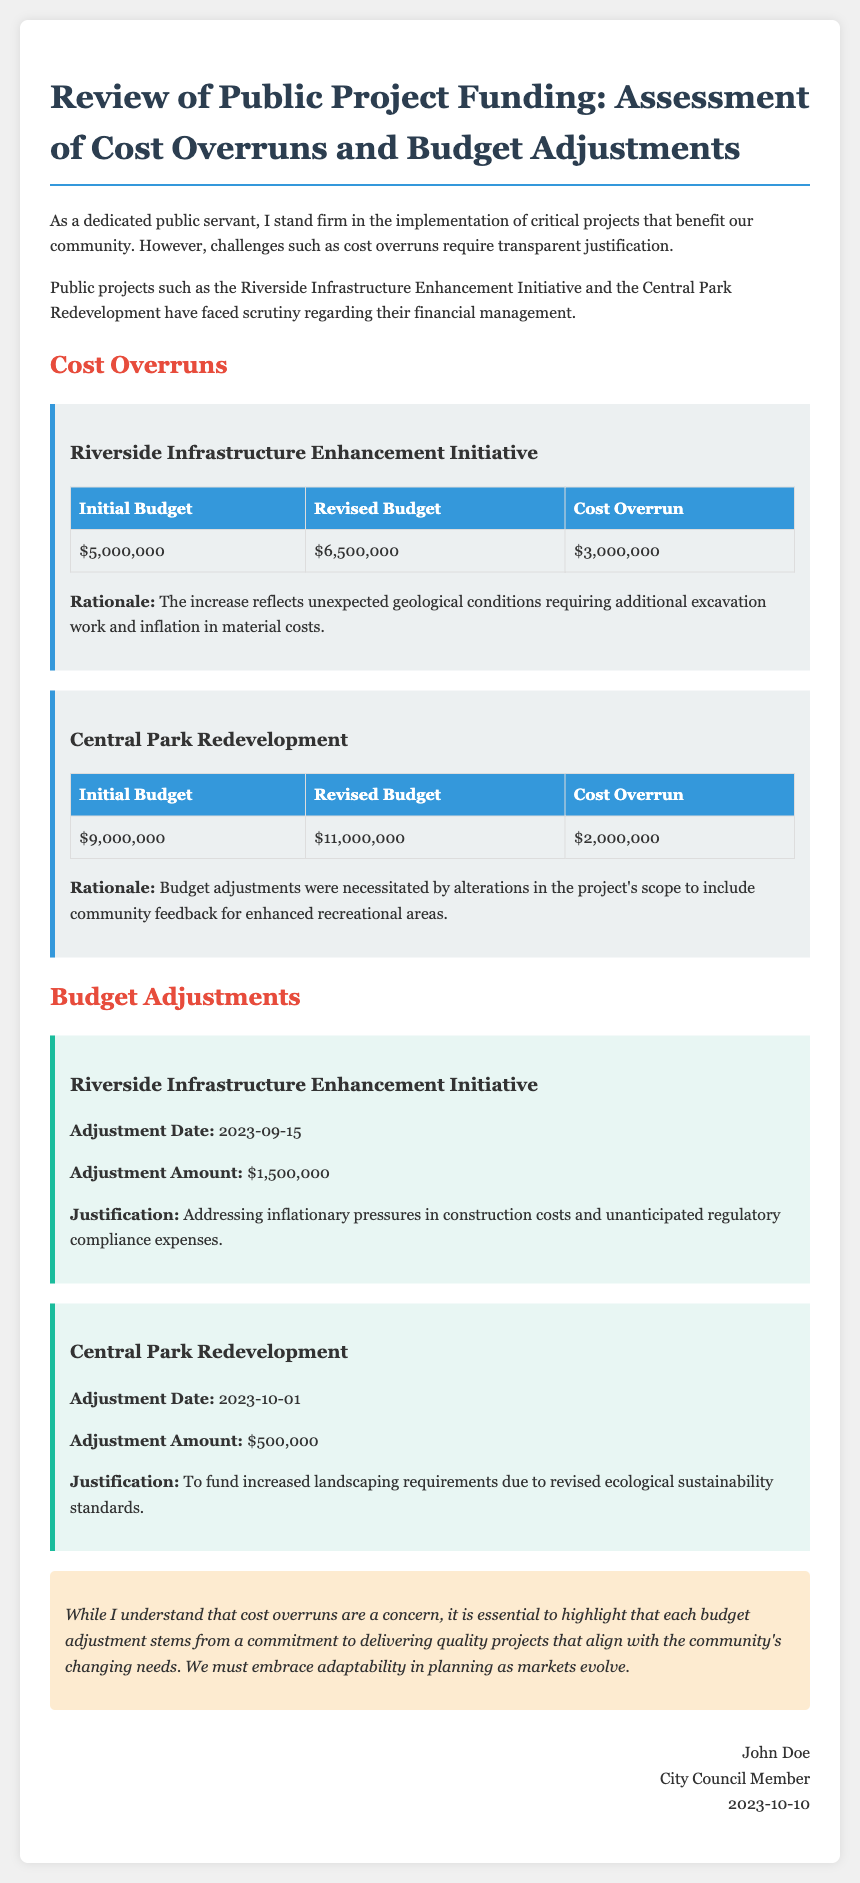What is the initial budget for the Riverside Infrastructure Enhancement Initiative? The initial budget is stated in the project funding table for the Riverside Infrastructure Enhancement Initiative, which is $5,000,000.
Answer: $5,000,000 What is the revised budget for the Central Park Redevelopment? The revised budget is provided in the project funding table for the Central Park Redevelopment, which is $11,000,000.
Answer: $11,000,000 How much did the Riverside Infrastructure Enhancement Initiative exceed its budget? The cost overrun is directly listed in the funding table for the Riverside Infrastructure Enhancement Initiative, amounting to $3,000,000.
Answer: $3,000,000 What was the adjustment amount for the Riverside Infrastructure Enhancement Initiative? The adjustment amount is specified in the budget adjustments section for the Riverside Infrastructure Enhancement Initiative, which is $1,500,000.
Answer: $1,500,000 What was the adjustment date for the Central Park Redevelopment? The adjustment date is listed in the budget adjustments section for the Central Park Redevelopment, which is 2023-10-01.
Answer: 2023-10-01 What caused the cost overrun in the Riverside Infrastructure Enhancement Initiative? The rationale for the cost overrun is mentioned, citing unexpected geological conditions requiring additional excavation work and inflation in material costs.
Answer: Unexpected geological conditions What was the justification for the budget adjustment for the Central Park Redevelopment? The justification is provided in the document, indicating that it was to fund increased landscaping requirements due to revised ecological sustainability standards.
Answer: Increased landscaping requirements What does the conclusion emphasize regarding budget adjustments? The conclusion highlights that budget adjustments stem from a commitment to delivering quality projects that align with community needs.
Answer: Commitment to quality projects What is the title of the document? The title of the document is stated at the beginning, which is Review of Public Project Funding: Assessment of Cost Overruns and Budget Adjustments.
Answer: Review of Public Project Funding: Assessment of Cost Overruns and Budget Adjustments 